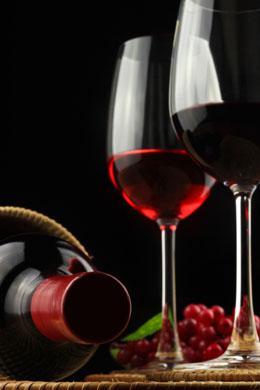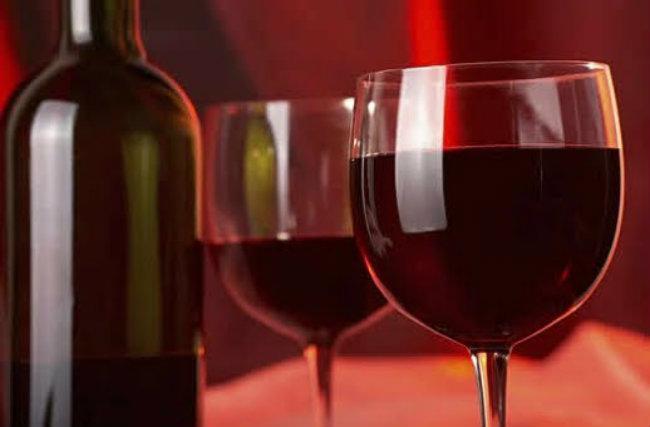The first image is the image on the left, the second image is the image on the right. Examine the images to the left and right. Is the description "There are more than two glasses with wine in them" accurate? Answer yes or no. Yes. The first image is the image on the left, the second image is the image on the right. Assess this claim about the two images: "There are four wine glasses, and some of them are in front of the others.". Correct or not? Answer yes or no. Yes. 